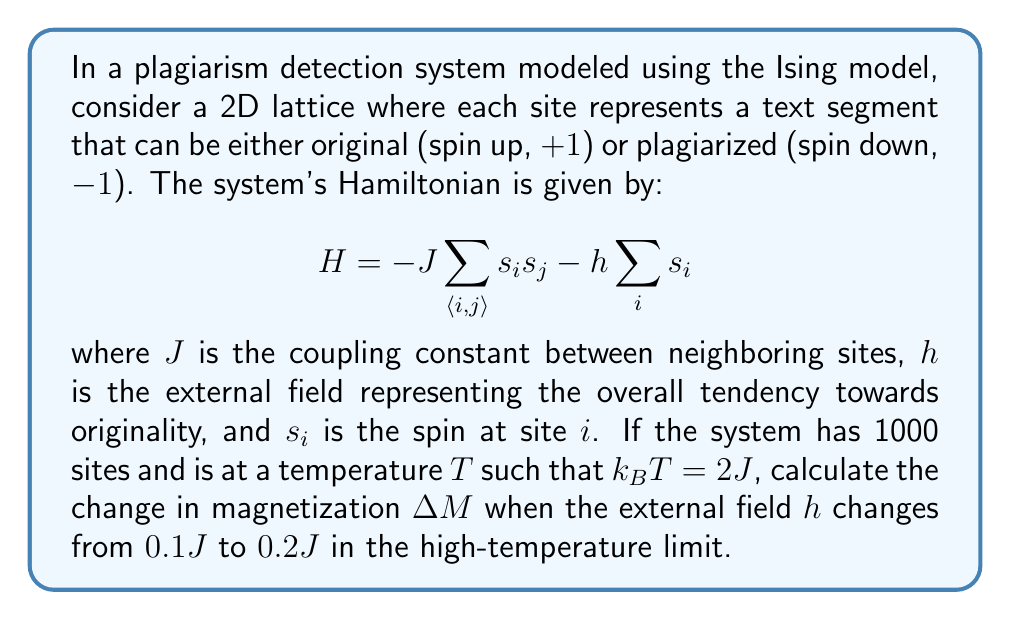Solve this math problem. To solve this problem, we'll follow these steps:

1) In the high-temperature limit of the Ising model, we can use the Curie-Weiss mean-field approximation. The magnetization $M$ in this limit is given by:

   $$ M = \tanh(\beta(zJM + h)) $$

   where $\beta = \frac{1}{k_B T}$, $z$ is the number of nearest neighbors, and $h$ is the external field.

2) We're given that $k_B T = 2J$, so $\beta = \frac{1}{2J}$.

3) For a 2D square lattice, $z = 4$.

4) In the high-temperature limit, $\beta zJ$ is small, so we can approximate the tanh function with its argument:

   $$ M \approx \beta(zJM + h) = \frac{1}{2J}(4JM + h) = 2M + \frac{h}{2J} $$

5) Solving for $M$:

   $$ M - 2M = \frac{h}{2J} $$
   $$ -M = \frac{h}{2J} $$
   $$ M = -\frac{h}{2J} $$

6) Now, we can calculate $M$ for both values of $h$:

   For $h = 0.1J$: $M_1 = -\frac{0.1J}{2J} = -0.05$
   
   For $h = 0.2J$: $M_2 = -\frac{0.2J}{2J} = -0.1$

7) The change in magnetization is:

   $$ \Delta M = M_2 - M_1 = -0.1 - (-0.05) = -0.05 $$

8) Since there are 1000 sites, the total change in magnetization is:

   $$ \Delta M_{total} = 1000 \times (-0.05) = -50 $$
Answer: $-50$ 